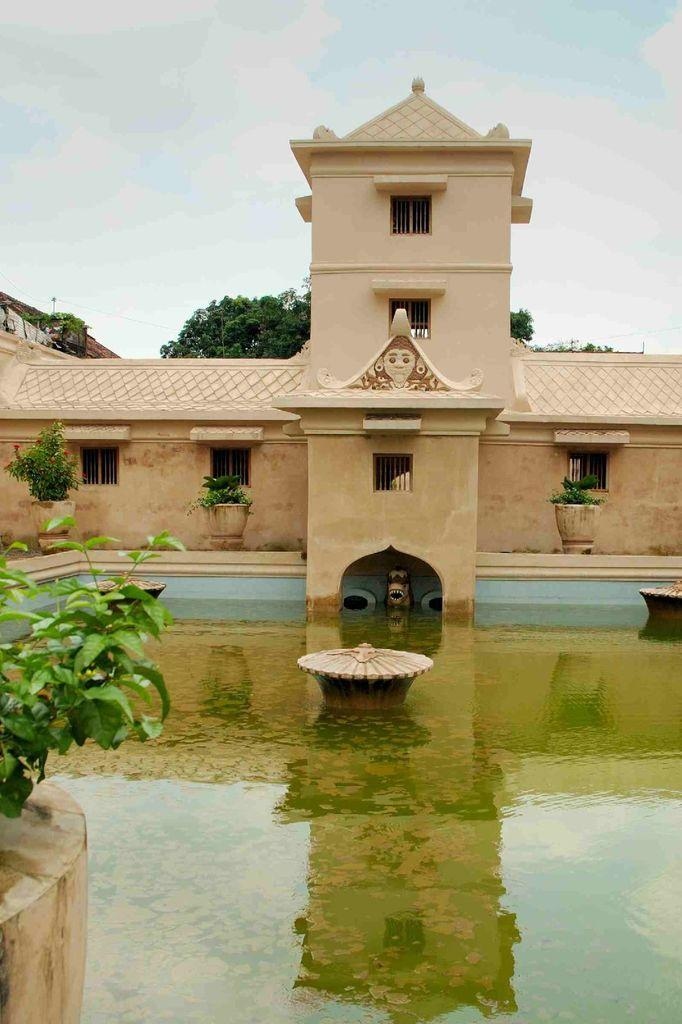What is the main element present in the image? There is water in the image. What can be seen on the left side of the image? There is a plant on the left side of the image. What type of structure is visible in the image? There is a house in the image. What objects are used for growing plants in the image? There are flower pots in the image. What type of vegetation is present in the image? There are trees in the image. How would you describe the weather in the image? The sky in the background is cloudy, suggesting a potentially overcast or rainy day. How many girls are playing the drum in the image? There are no girls or drums present in the image. 